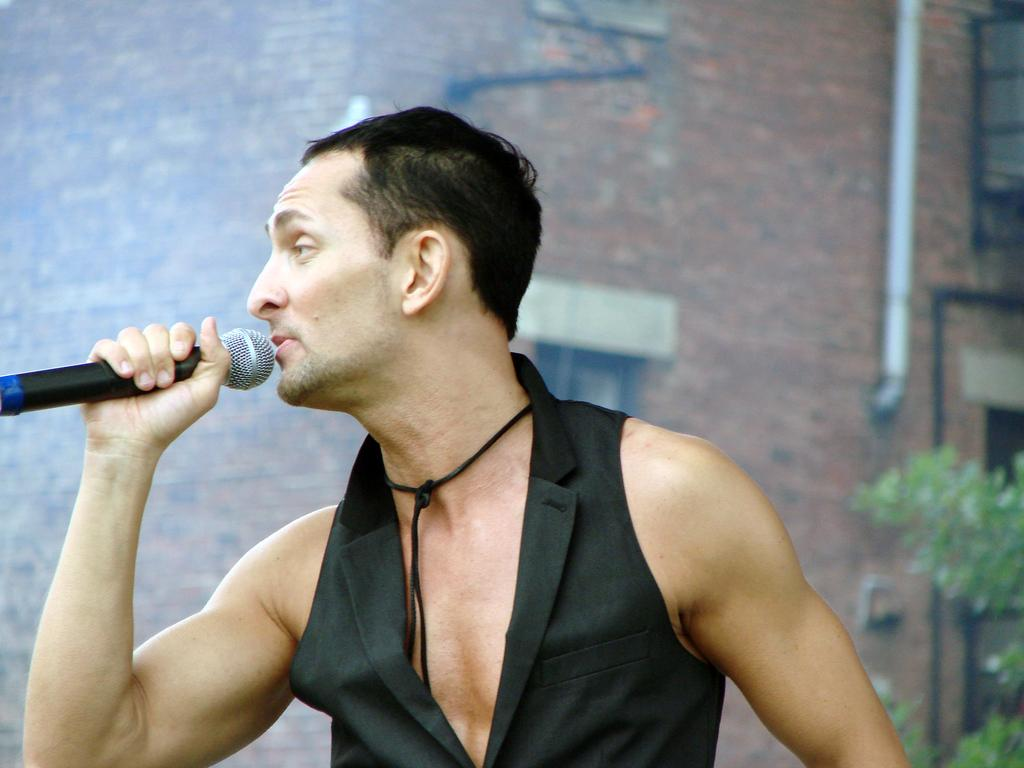Who is present in the image? There is a man in the image. What is the man holding in the image? The man is holding a mic. What type of drum can be seen in the image? There is no drum present in the image. Is the man in the image using a blade for any activity? There is no blade present in the image, and the man is not performing any activity that would require a blade. 